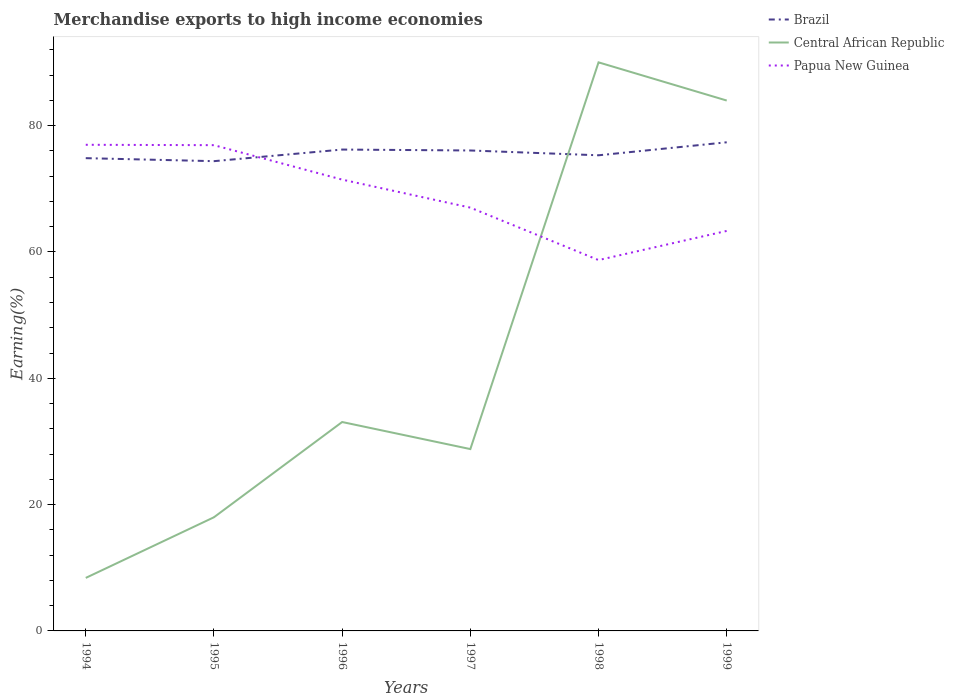How many different coloured lines are there?
Offer a very short reply. 3. Does the line corresponding to Brazil intersect with the line corresponding to Central African Republic?
Provide a short and direct response. Yes. Is the number of lines equal to the number of legend labels?
Your answer should be compact. Yes. Across all years, what is the maximum percentage of amount earned from merchandise exports in Brazil?
Provide a succinct answer. 74.38. In which year was the percentage of amount earned from merchandise exports in Central African Republic maximum?
Provide a succinct answer. 1994. What is the total percentage of amount earned from merchandise exports in Brazil in the graph?
Your answer should be very brief. -2.99. What is the difference between the highest and the second highest percentage of amount earned from merchandise exports in Brazil?
Make the answer very short. 2.99. What is the difference between the highest and the lowest percentage of amount earned from merchandise exports in Central African Republic?
Make the answer very short. 2. How many lines are there?
Provide a succinct answer. 3. How many years are there in the graph?
Ensure brevity in your answer.  6. Where does the legend appear in the graph?
Your response must be concise. Top right. How are the legend labels stacked?
Your answer should be very brief. Vertical. What is the title of the graph?
Keep it short and to the point. Merchandise exports to high income economies. What is the label or title of the Y-axis?
Your answer should be compact. Earning(%). What is the Earning(%) of Brazil in 1994?
Ensure brevity in your answer.  74.86. What is the Earning(%) of Central African Republic in 1994?
Offer a terse response. 8.39. What is the Earning(%) in Papua New Guinea in 1994?
Make the answer very short. 76.98. What is the Earning(%) of Brazil in 1995?
Give a very brief answer. 74.38. What is the Earning(%) in Central African Republic in 1995?
Keep it short and to the point. 18. What is the Earning(%) of Papua New Guinea in 1995?
Your answer should be compact. 76.92. What is the Earning(%) of Brazil in 1996?
Ensure brevity in your answer.  76.22. What is the Earning(%) of Central African Republic in 1996?
Your response must be concise. 33.08. What is the Earning(%) in Papua New Guinea in 1996?
Offer a very short reply. 71.46. What is the Earning(%) of Brazil in 1997?
Ensure brevity in your answer.  76.07. What is the Earning(%) of Central African Republic in 1997?
Ensure brevity in your answer.  28.79. What is the Earning(%) of Papua New Guinea in 1997?
Your answer should be compact. 67.03. What is the Earning(%) of Brazil in 1998?
Your answer should be very brief. 75.31. What is the Earning(%) in Central African Republic in 1998?
Your answer should be compact. 90.03. What is the Earning(%) of Papua New Guinea in 1998?
Your answer should be very brief. 58.72. What is the Earning(%) in Brazil in 1999?
Give a very brief answer. 77.37. What is the Earning(%) of Central African Republic in 1999?
Provide a succinct answer. 83.98. What is the Earning(%) of Papua New Guinea in 1999?
Offer a very short reply. 63.34. Across all years, what is the maximum Earning(%) in Brazil?
Your answer should be very brief. 77.37. Across all years, what is the maximum Earning(%) of Central African Republic?
Your answer should be very brief. 90.03. Across all years, what is the maximum Earning(%) of Papua New Guinea?
Keep it short and to the point. 76.98. Across all years, what is the minimum Earning(%) in Brazil?
Provide a short and direct response. 74.38. Across all years, what is the minimum Earning(%) of Central African Republic?
Make the answer very short. 8.39. Across all years, what is the minimum Earning(%) of Papua New Guinea?
Your response must be concise. 58.72. What is the total Earning(%) in Brazil in the graph?
Offer a terse response. 454.22. What is the total Earning(%) in Central African Republic in the graph?
Keep it short and to the point. 262.27. What is the total Earning(%) of Papua New Guinea in the graph?
Ensure brevity in your answer.  414.43. What is the difference between the Earning(%) in Brazil in 1994 and that in 1995?
Ensure brevity in your answer.  0.48. What is the difference between the Earning(%) of Central African Republic in 1994 and that in 1995?
Provide a short and direct response. -9.6. What is the difference between the Earning(%) of Papua New Guinea in 1994 and that in 1995?
Your response must be concise. 0.06. What is the difference between the Earning(%) in Brazil in 1994 and that in 1996?
Your answer should be compact. -1.36. What is the difference between the Earning(%) in Central African Republic in 1994 and that in 1996?
Keep it short and to the point. -24.68. What is the difference between the Earning(%) of Papua New Guinea in 1994 and that in 1996?
Provide a succinct answer. 5.52. What is the difference between the Earning(%) in Brazil in 1994 and that in 1997?
Give a very brief answer. -1.22. What is the difference between the Earning(%) in Central African Republic in 1994 and that in 1997?
Offer a terse response. -20.4. What is the difference between the Earning(%) of Papua New Guinea in 1994 and that in 1997?
Offer a very short reply. 9.95. What is the difference between the Earning(%) in Brazil in 1994 and that in 1998?
Give a very brief answer. -0.45. What is the difference between the Earning(%) of Central African Republic in 1994 and that in 1998?
Your answer should be compact. -81.63. What is the difference between the Earning(%) in Papua New Guinea in 1994 and that in 1998?
Offer a very short reply. 18.25. What is the difference between the Earning(%) in Brazil in 1994 and that in 1999?
Ensure brevity in your answer.  -2.51. What is the difference between the Earning(%) in Central African Republic in 1994 and that in 1999?
Your answer should be very brief. -75.59. What is the difference between the Earning(%) of Papua New Guinea in 1994 and that in 1999?
Provide a short and direct response. 13.64. What is the difference between the Earning(%) of Brazil in 1995 and that in 1996?
Offer a terse response. -1.84. What is the difference between the Earning(%) in Central African Republic in 1995 and that in 1996?
Give a very brief answer. -15.08. What is the difference between the Earning(%) in Papua New Guinea in 1995 and that in 1996?
Provide a short and direct response. 5.46. What is the difference between the Earning(%) of Brazil in 1995 and that in 1997?
Provide a succinct answer. -1.69. What is the difference between the Earning(%) of Central African Republic in 1995 and that in 1997?
Ensure brevity in your answer.  -10.8. What is the difference between the Earning(%) of Papua New Guinea in 1995 and that in 1997?
Your response must be concise. 9.89. What is the difference between the Earning(%) of Brazil in 1995 and that in 1998?
Provide a succinct answer. -0.93. What is the difference between the Earning(%) in Central African Republic in 1995 and that in 1998?
Ensure brevity in your answer.  -72.03. What is the difference between the Earning(%) in Papua New Guinea in 1995 and that in 1998?
Provide a succinct answer. 18.19. What is the difference between the Earning(%) of Brazil in 1995 and that in 1999?
Make the answer very short. -2.99. What is the difference between the Earning(%) of Central African Republic in 1995 and that in 1999?
Keep it short and to the point. -65.98. What is the difference between the Earning(%) of Papua New Guinea in 1995 and that in 1999?
Keep it short and to the point. 13.58. What is the difference between the Earning(%) of Brazil in 1996 and that in 1997?
Make the answer very short. 0.15. What is the difference between the Earning(%) in Central African Republic in 1996 and that in 1997?
Your answer should be very brief. 4.29. What is the difference between the Earning(%) in Papua New Guinea in 1996 and that in 1997?
Give a very brief answer. 4.43. What is the difference between the Earning(%) of Brazil in 1996 and that in 1998?
Your answer should be very brief. 0.91. What is the difference between the Earning(%) in Central African Republic in 1996 and that in 1998?
Provide a succinct answer. -56.95. What is the difference between the Earning(%) of Papua New Guinea in 1996 and that in 1998?
Provide a short and direct response. 12.74. What is the difference between the Earning(%) in Brazil in 1996 and that in 1999?
Offer a very short reply. -1.15. What is the difference between the Earning(%) of Central African Republic in 1996 and that in 1999?
Give a very brief answer. -50.9. What is the difference between the Earning(%) of Papua New Guinea in 1996 and that in 1999?
Make the answer very short. 8.12. What is the difference between the Earning(%) in Brazil in 1997 and that in 1998?
Your response must be concise. 0.76. What is the difference between the Earning(%) in Central African Republic in 1997 and that in 1998?
Make the answer very short. -61.23. What is the difference between the Earning(%) in Papua New Guinea in 1997 and that in 1998?
Offer a very short reply. 8.3. What is the difference between the Earning(%) of Brazil in 1997 and that in 1999?
Offer a very short reply. -1.3. What is the difference between the Earning(%) of Central African Republic in 1997 and that in 1999?
Offer a very short reply. -55.19. What is the difference between the Earning(%) of Papua New Guinea in 1997 and that in 1999?
Provide a short and direct response. 3.69. What is the difference between the Earning(%) of Brazil in 1998 and that in 1999?
Keep it short and to the point. -2.06. What is the difference between the Earning(%) of Central African Republic in 1998 and that in 1999?
Ensure brevity in your answer.  6.05. What is the difference between the Earning(%) of Papua New Guinea in 1998 and that in 1999?
Keep it short and to the point. -4.62. What is the difference between the Earning(%) of Brazil in 1994 and the Earning(%) of Central African Republic in 1995?
Your answer should be very brief. 56.86. What is the difference between the Earning(%) of Brazil in 1994 and the Earning(%) of Papua New Guinea in 1995?
Keep it short and to the point. -2.06. What is the difference between the Earning(%) of Central African Republic in 1994 and the Earning(%) of Papua New Guinea in 1995?
Offer a terse response. -68.52. What is the difference between the Earning(%) in Brazil in 1994 and the Earning(%) in Central African Republic in 1996?
Keep it short and to the point. 41.78. What is the difference between the Earning(%) of Brazil in 1994 and the Earning(%) of Papua New Guinea in 1996?
Ensure brevity in your answer.  3.4. What is the difference between the Earning(%) of Central African Republic in 1994 and the Earning(%) of Papua New Guinea in 1996?
Give a very brief answer. -63.07. What is the difference between the Earning(%) in Brazil in 1994 and the Earning(%) in Central African Republic in 1997?
Your response must be concise. 46.07. What is the difference between the Earning(%) of Brazil in 1994 and the Earning(%) of Papua New Guinea in 1997?
Make the answer very short. 7.83. What is the difference between the Earning(%) of Central African Republic in 1994 and the Earning(%) of Papua New Guinea in 1997?
Keep it short and to the point. -58.63. What is the difference between the Earning(%) in Brazil in 1994 and the Earning(%) in Central African Republic in 1998?
Provide a short and direct response. -15.17. What is the difference between the Earning(%) of Brazil in 1994 and the Earning(%) of Papua New Guinea in 1998?
Your answer should be very brief. 16.14. What is the difference between the Earning(%) in Central African Republic in 1994 and the Earning(%) in Papua New Guinea in 1998?
Ensure brevity in your answer.  -50.33. What is the difference between the Earning(%) of Brazil in 1994 and the Earning(%) of Central African Republic in 1999?
Your response must be concise. -9.12. What is the difference between the Earning(%) of Brazil in 1994 and the Earning(%) of Papua New Guinea in 1999?
Your answer should be compact. 11.52. What is the difference between the Earning(%) in Central African Republic in 1994 and the Earning(%) in Papua New Guinea in 1999?
Your response must be concise. -54.94. What is the difference between the Earning(%) of Brazil in 1995 and the Earning(%) of Central African Republic in 1996?
Offer a very short reply. 41.3. What is the difference between the Earning(%) in Brazil in 1995 and the Earning(%) in Papua New Guinea in 1996?
Your answer should be very brief. 2.92. What is the difference between the Earning(%) of Central African Republic in 1995 and the Earning(%) of Papua New Guinea in 1996?
Provide a succinct answer. -53.46. What is the difference between the Earning(%) of Brazil in 1995 and the Earning(%) of Central African Republic in 1997?
Make the answer very short. 45.59. What is the difference between the Earning(%) of Brazil in 1995 and the Earning(%) of Papua New Guinea in 1997?
Your answer should be compact. 7.36. What is the difference between the Earning(%) in Central African Republic in 1995 and the Earning(%) in Papua New Guinea in 1997?
Ensure brevity in your answer.  -49.03. What is the difference between the Earning(%) of Brazil in 1995 and the Earning(%) of Central African Republic in 1998?
Make the answer very short. -15.65. What is the difference between the Earning(%) of Brazil in 1995 and the Earning(%) of Papua New Guinea in 1998?
Your answer should be very brief. 15.66. What is the difference between the Earning(%) of Central African Republic in 1995 and the Earning(%) of Papua New Guinea in 1998?
Offer a terse response. -40.72. What is the difference between the Earning(%) in Brazil in 1995 and the Earning(%) in Central African Republic in 1999?
Offer a very short reply. -9.6. What is the difference between the Earning(%) of Brazil in 1995 and the Earning(%) of Papua New Guinea in 1999?
Give a very brief answer. 11.04. What is the difference between the Earning(%) in Central African Republic in 1995 and the Earning(%) in Papua New Guinea in 1999?
Your answer should be compact. -45.34. What is the difference between the Earning(%) of Brazil in 1996 and the Earning(%) of Central African Republic in 1997?
Make the answer very short. 47.43. What is the difference between the Earning(%) in Brazil in 1996 and the Earning(%) in Papua New Guinea in 1997?
Your answer should be very brief. 9.2. What is the difference between the Earning(%) of Central African Republic in 1996 and the Earning(%) of Papua New Guinea in 1997?
Your answer should be compact. -33.95. What is the difference between the Earning(%) in Brazil in 1996 and the Earning(%) in Central African Republic in 1998?
Give a very brief answer. -13.81. What is the difference between the Earning(%) in Brazil in 1996 and the Earning(%) in Papua New Guinea in 1998?
Ensure brevity in your answer.  17.5. What is the difference between the Earning(%) of Central African Republic in 1996 and the Earning(%) of Papua New Guinea in 1998?
Make the answer very short. -25.64. What is the difference between the Earning(%) of Brazil in 1996 and the Earning(%) of Central African Republic in 1999?
Your response must be concise. -7.76. What is the difference between the Earning(%) of Brazil in 1996 and the Earning(%) of Papua New Guinea in 1999?
Provide a succinct answer. 12.88. What is the difference between the Earning(%) of Central African Republic in 1996 and the Earning(%) of Papua New Guinea in 1999?
Keep it short and to the point. -30.26. What is the difference between the Earning(%) of Brazil in 1997 and the Earning(%) of Central African Republic in 1998?
Your response must be concise. -13.95. What is the difference between the Earning(%) in Brazil in 1997 and the Earning(%) in Papua New Guinea in 1998?
Your answer should be very brief. 17.35. What is the difference between the Earning(%) in Central African Republic in 1997 and the Earning(%) in Papua New Guinea in 1998?
Your response must be concise. -29.93. What is the difference between the Earning(%) of Brazil in 1997 and the Earning(%) of Central African Republic in 1999?
Make the answer very short. -7.91. What is the difference between the Earning(%) of Brazil in 1997 and the Earning(%) of Papua New Guinea in 1999?
Offer a very short reply. 12.74. What is the difference between the Earning(%) of Central African Republic in 1997 and the Earning(%) of Papua New Guinea in 1999?
Offer a terse response. -34.54. What is the difference between the Earning(%) of Brazil in 1998 and the Earning(%) of Central African Republic in 1999?
Ensure brevity in your answer.  -8.67. What is the difference between the Earning(%) of Brazil in 1998 and the Earning(%) of Papua New Guinea in 1999?
Offer a terse response. 11.98. What is the difference between the Earning(%) of Central African Republic in 1998 and the Earning(%) of Papua New Guinea in 1999?
Your response must be concise. 26.69. What is the average Earning(%) in Brazil per year?
Give a very brief answer. 75.7. What is the average Earning(%) in Central African Republic per year?
Ensure brevity in your answer.  43.71. What is the average Earning(%) of Papua New Guinea per year?
Keep it short and to the point. 69.07. In the year 1994, what is the difference between the Earning(%) in Brazil and Earning(%) in Central African Republic?
Your response must be concise. 66.46. In the year 1994, what is the difference between the Earning(%) in Brazil and Earning(%) in Papua New Guinea?
Offer a very short reply. -2.12. In the year 1994, what is the difference between the Earning(%) of Central African Republic and Earning(%) of Papua New Guinea?
Provide a succinct answer. -68.58. In the year 1995, what is the difference between the Earning(%) of Brazil and Earning(%) of Central African Republic?
Ensure brevity in your answer.  56.38. In the year 1995, what is the difference between the Earning(%) of Brazil and Earning(%) of Papua New Guinea?
Ensure brevity in your answer.  -2.53. In the year 1995, what is the difference between the Earning(%) of Central African Republic and Earning(%) of Papua New Guinea?
Offer a terse response. -58.92. In the year 1996, what is the difference between the Earning(%) of Brazil and Earning(%) of Central African Republic?
Offer a very short reply. 43.14. In the year 1996, what is the difference between the Earning(%) in Brazil and Earning(%) in Papua New Guinea?
Ensure brevity in your answer.  4.76. In the year 1996, what is the difference between the Earning(%) of Central African Republic and Earning(%) of Papua New Guinea?
Offer a terse response. -38.38. In the year 1997, what is the difference between the Earning(%) of Brazil and Earning(%) of Central African Republic?
Your response must be concise. 47.28. In the year 1997, what is the difference between the Earning(%) of Brazil and Earning(%) of Papua New Guinea?
Provide a succinct answer. 9.05. In the year 1997, what is the difference between the Earning(%) in Central African Republic and Earning(%) in Papua New Guinea?
Your response must be concise. -38.23. In the year 1998, what is the difference between the Earning(%) of Brazil and Earning(%) of Central African Republic?
Offer a very short reply. -14.72. In the year 1998, what is the difference between the Earning(%) in Brazil and Earning(%) in Papua New Guinea?
Give a very brief answer. 16.59. In the year 1998, what is the difference between the Earning(%) of Central African Republic and Earning(%) of Papua New Guinea?
Your response must be concise. 31.31. In the year 1999, what is the difference between the Earning(%) in Brazil and Earning(%) in Central African Republic?
Your answer should be compact. -6.61. In the year 1999, what is the difference between the Earning(%) of Brazil and Earning(%) of Papua New Guinea?
Provide a succinct answer. 14.03. In the year 1999, what is the difference between the Earning(%) of Central African Republic and Earning(%) of Papua New Guinea?
Ensure brevity in your answer.  20.65. What is the ratio of the Earning(%) of Brazil in 1994 to that in 1995?
Make the answer very short. 1.01. What is the ratio of the Earning(%) in Central African Republic in 1994 to that in 1995?
Your response must be concise. 0.47. What is the ratio of the Earning(%) of Brazil in 1994 to that in 1996?
Offer a terse response. 0.98. What is the ratio of the Earning(%) of Central African Republic in 1994 to that in 1996?
Your answer should be compact. 0.25. What is the ratio of the Earning(%) in Papua New Guinea in 1994 to that in 1996?
Ensure brevity in your answer.  1.08. What is the ratio of the Earning(%) in Brazil in 1994 to that in 1997?
Keep it short and to the point. 0.98. What is the ratio of the Earning(%) in Central African Republic in 1994 to that in 1997?
Provide a short and direct response. 0.29. What is the ratio of the Earning(%) of Papua New Guinea in 1994 to that in 1997?
Make the answer very short. 1.15. What is the ratio of the Earning(%) of Brazil in 1994 to that in 1998?
Make the answer very short. 0.99. What is the ratio of the Earning(%) of Central African Republic in 1994 to that in 1998?
Give a very brief answer. 0.09. What is the ratio of the Earning(%) of Papua New Guinea in 1994 to that in 1998?
Your response must be concise. 1.31. What is the ratio of the Earning(%) of Brazil in 1994 to that in 1999?
Your answer should be very brief. 0.97. What is the ratio of the Earning(%) in Central African Republic in 1994 to that in 1999?
Your answer should be compact. 0.1. What is the ratio of the Earning(%) of Papua New Guinea in 1994 to that in 1999?
Your answer should be compact. 1.22. What is the ratio of the Earning(%) of Brazil in 1995 to that in 1996?
Keep it short and to the point. 0.98. What is the ratio of the Earning(%) in Central African Republic in 1995 to that in 1996?
Offer a very short reply. 0.54. What is the ratio of the Earning(%) in Papua New Guinea in 1995 to that in 1996?
Keep it short and to the point. 1.08. What is the ratio of the Earning(%) of Brazil in 1995 to that in 1997?
Ensure brevity in your answer.  0.98. What is the ratio of the Earning(%) of Central African Republic in 1995 to that in 1997?
Your answer should be very brief. 0.63. What is the ratio of the Earning(%) of Papua New Guinea in 1995 to that in 1997?
Provide a short and direct response. 1.15. What is the ratio of the Earning(%) in Brazil in 1995 to that in 1998?
Your answer should be compact. 0.99. What is the ratio of the Earning(%) in Central African Republic in 1995 to that in 1998?
Offer a terse response. 0.2. What is the ratio of the Earning(%) of Papua New Guinea in 1995 to that in 1998?
Ensure brevity in your answer.  1.31. What is the ratio of the Earning(%) of Brazil in 1995 to that in 1999?
Provide a short and direct response. 0.96. What is the ratio of the Earning(%) of Central African Republic in 1995 to that in 1999?
Offer a terse response. 0.21. What is the ratio of the Earning(%) of Papua New Guinea in 1995 to that in 1999?
Your answer should be very brief. 1.21. What is the ratio of the Earning(%) in Brazil in 1996 to that in 1997?
Provide a short and direct response. 1. What is the ratio of the Earning(%) of Central African Republic in 1996 to that in 1997?
Provide a short and direct response. 1.15. What is the ratio of the Earning(%) of Papua New Guinea in 1996 to that in 1997?
Keep it short and to the point. 1.07. What is the ratio of the Earning(%) in Brazil in 1996 to that in 1998?
Offer a very short reply. 1.01. What is the ratio of the Earning(%) in Central African Republic in 1996 to that in 1998?
Give a very brief answer. 0.37. What is the ratio of the Earning(%) in Papua New Guinea in 1996 to that in 1998?
Ensure brevity in your answer.  1.22. What is the ratio of the Earning(%) of Brazil in 1996 to that in 1999?
Provide a short and direct response. 0.99. What is the ratio of the Earning(%) in Central African Republic in 1996 to that in 1999?
Offer a terse response. 0.39. What is the ratio of the Earning(%) of Papua New Guinea in 1996 to that in 1999?
Provide a short and direct response. 1.13. What is the ratio of the Earning(%) of Brazil in 1997 to that in 1998?
Provide a succinct answer. 1.01. What is the ratio of the Earning(%) in Central African Republic in 1997 to that in 1998?
Ensure brevity in your answer.  0.32. What is the ratio of the Earning(%) of Papua New Guinea in 1997 to that in 1998?
Provide a succinct answer. 1.14. What is the ratio of the Earning(%) in Brazil in 1997 to that in 1999?
Ensure brevity in your answer.  0.98. What is the ratio of the Earning(%) in Central African Republic in 1997 to that in 1999?
Offer a very short reply. 0.34. What is the ratio of the Earning(%) in Papua New Guinea in 1997 to that in 1999?
Your response must be concise. 1.06. What is the ratio of the Earning(%) of Brazil in 1998 to that in 1999?
Provide a short and direct response. 0.97. What is the ratio of the Earning(%) in Central African Republic in 1998 to that in 1999?
Give a very brief answer. 1.07. What is the ratio of the Earning(%) in Papua New Guinea in 1998 to that in 1999?
Make the answer very short. 0.93. What is the difference between the highest and the second highest Earning(%) of Brazil?
Your answer should be compact. 1.15. What is the difference between the highest and the second highest Earning(%) in Central African Republic?
Your response must be concise. 6.05. What is the difference between the highest and the lowest Earning(%) of Brazil?
Your answer should be very brief. 2.99. What is the difference between the highest and the lowest Earning(%) of Central African Republic?
Your response must be concise. 81.63. What is the difference between the highest and the lowest Earning(%) in Papua New Guinea?
Your response must be concise. 18.25. 